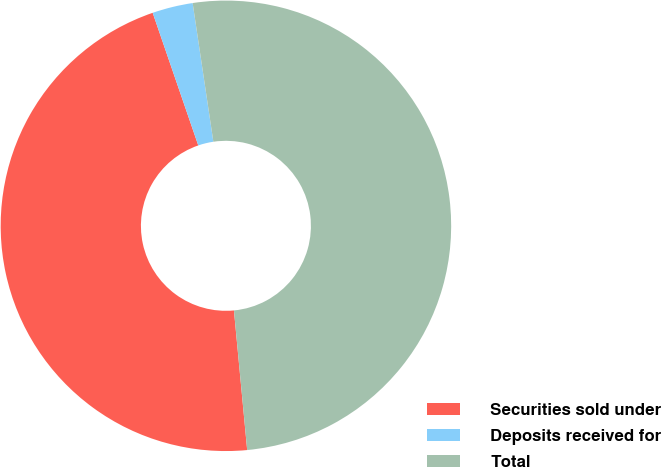<chart> <loc_0><loc_0><loc_500><loc_500><pie_chart><fcel>Securities sold under<fcel>Deposits received for<fcel>Total<nl><fcel>46.23%<fcel>2.91%<fcel>50.85%<nl></chart> 